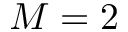Convert formula to latex. <formula><loc_0><loc_0><loc_500><loc_500>M = 2</formula> 